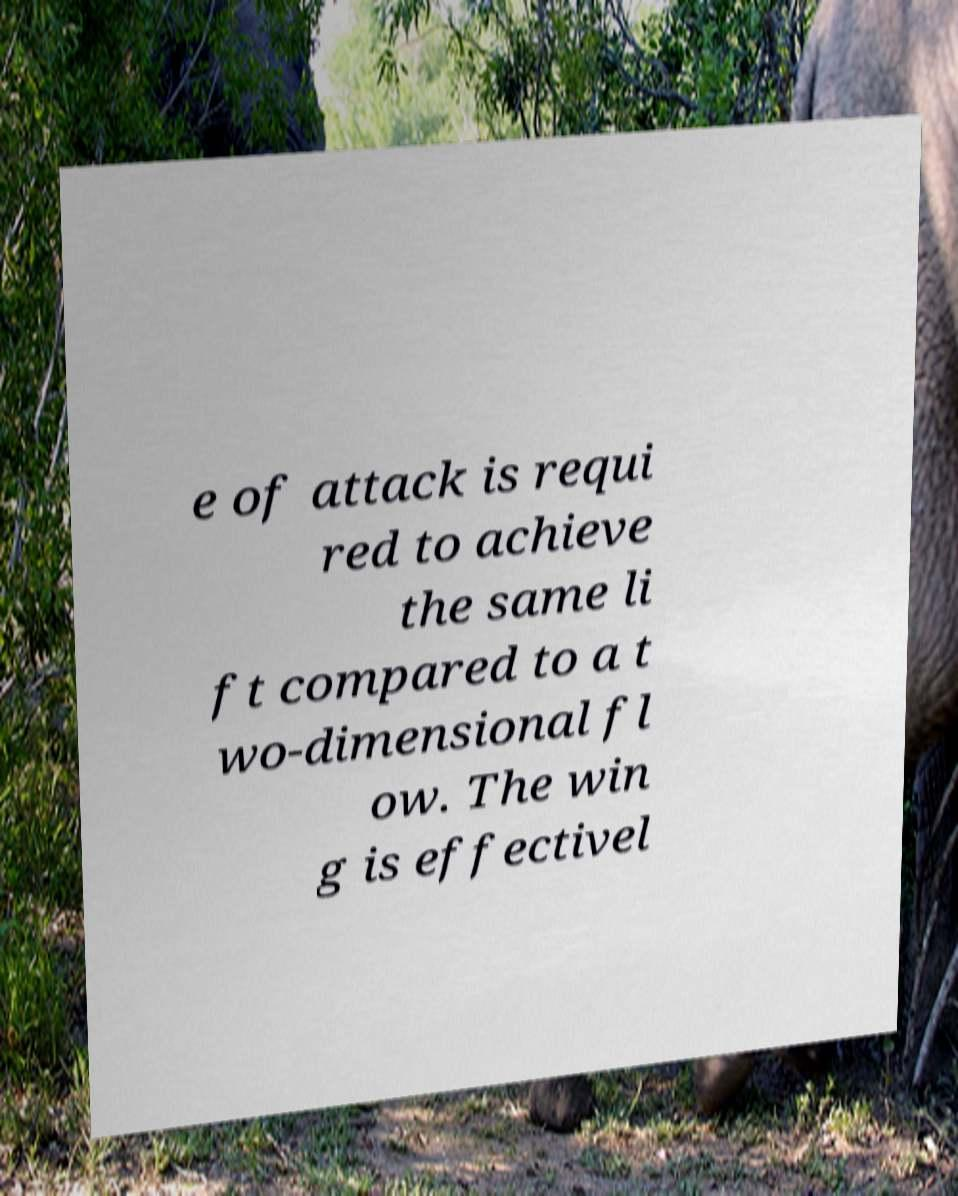Can you read and provide the text displayed in the image?This photo seems to have some interesting text. Can you extract and type it out for me? e of attack is requi red to achieve the same li ft compared to a t wo-dimensional fl ow. The win g is effectivel 